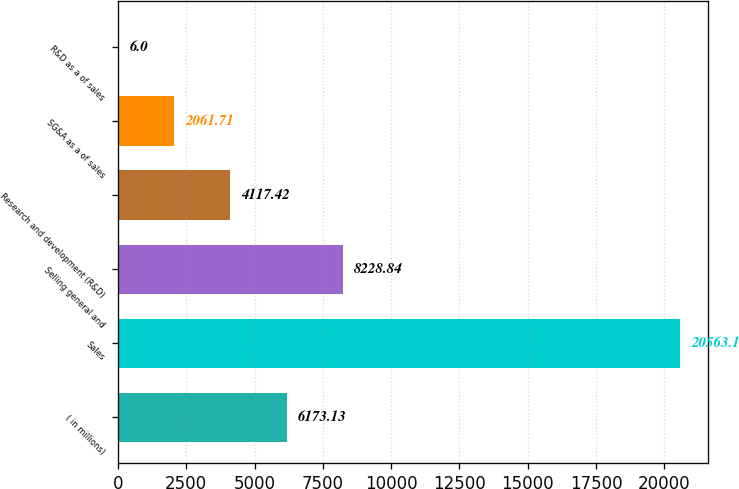Convert chart to OTSL. <chart><loc_0><loc_0><loc_500><loc_500><bar_chart><fcel>( in millions)<fcel>Sales<fcel>Selling general and<fcel>Research and development (R&D)<fcel>SG&A as a of sales<fcel>R&D as a of sales<nl><fcel>6173.13<fcel>20563.1<fcel>8228.84<fcel>4117.42<fcel>2061.71<fcel>6<nl></chart> 